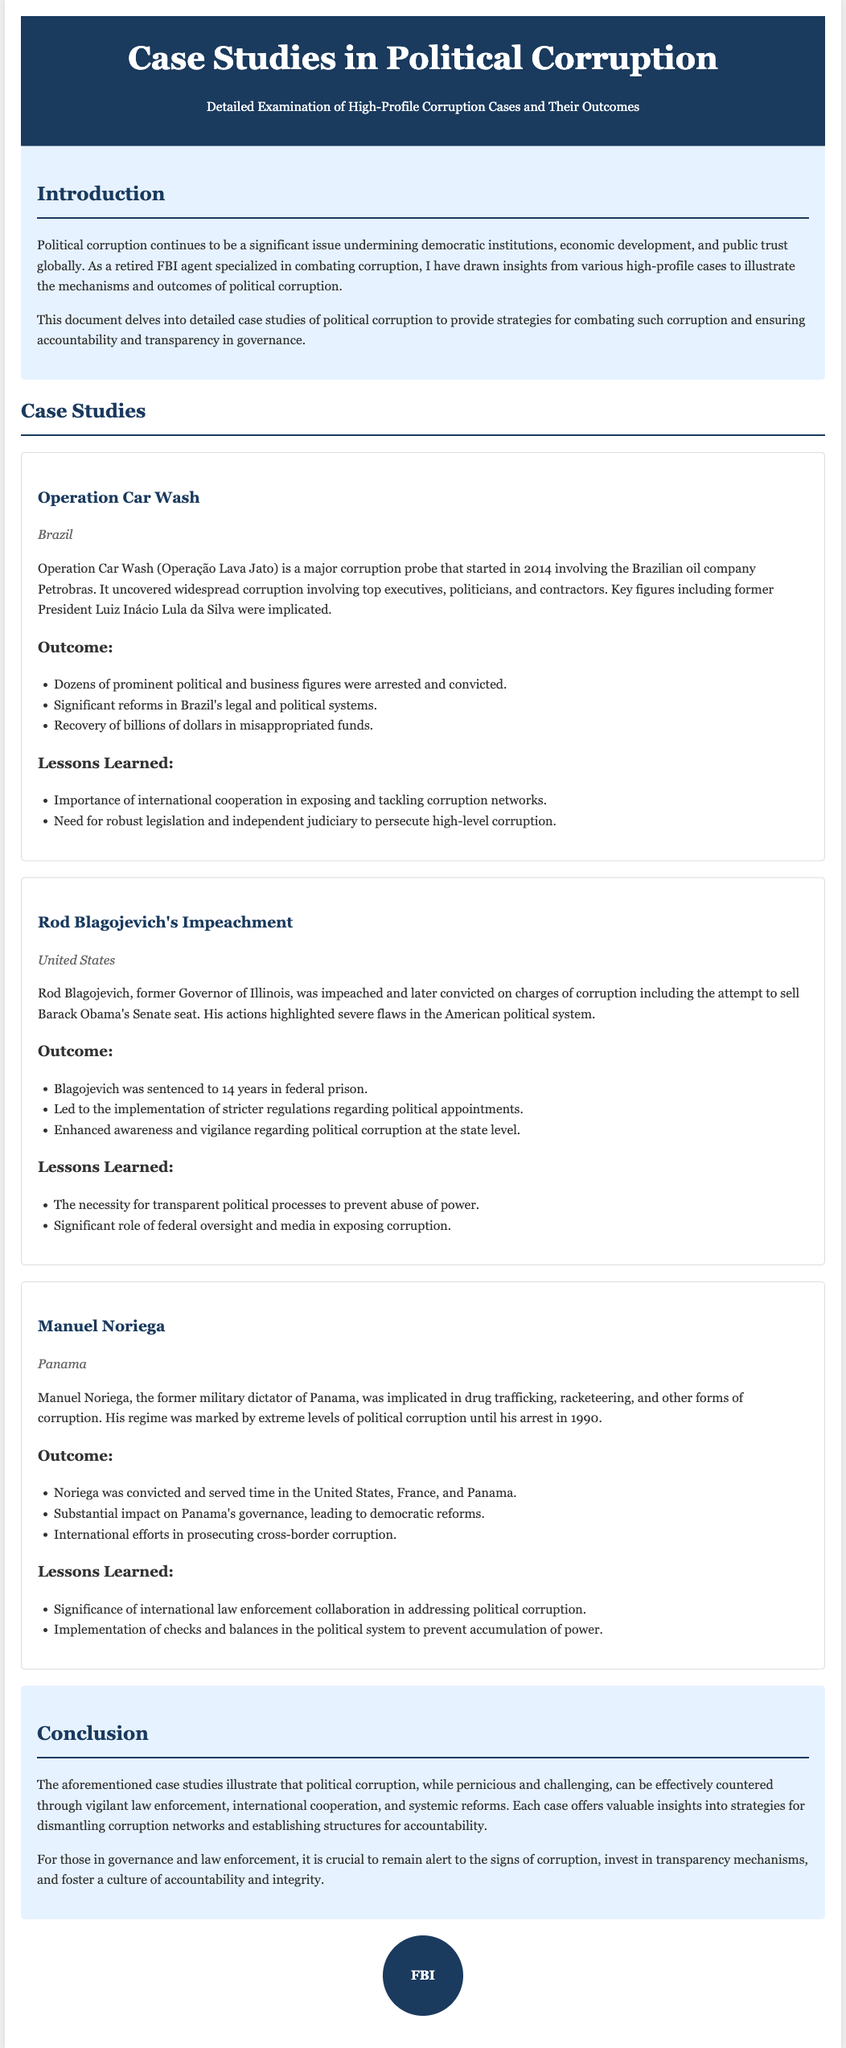What is the title of the document? The title of the document is provided in the header section.
Answer: Case Studies in Political Corruption In which country did Operation Car Wash occur? The location of Operation Car Wash is specified in the case study section.
Answer: Brazil How many years was Rod Blagojevich sentenced to prison? The sentence duration for Rod Blagojevich is stated in the outcome section of his case study.
Answer: 14 years What international effort was highlighted in Manuel Noriega's case? The lessons learned section mentions an aspect of international collaboration related to his case.
Answer: Collaboration in addressing political corruption What reform was a result of Rod Blagojevich's impeachment? The outcomes section lists a specific regulation change following his case.
Answer: Stricter regulations regarding political appointments 